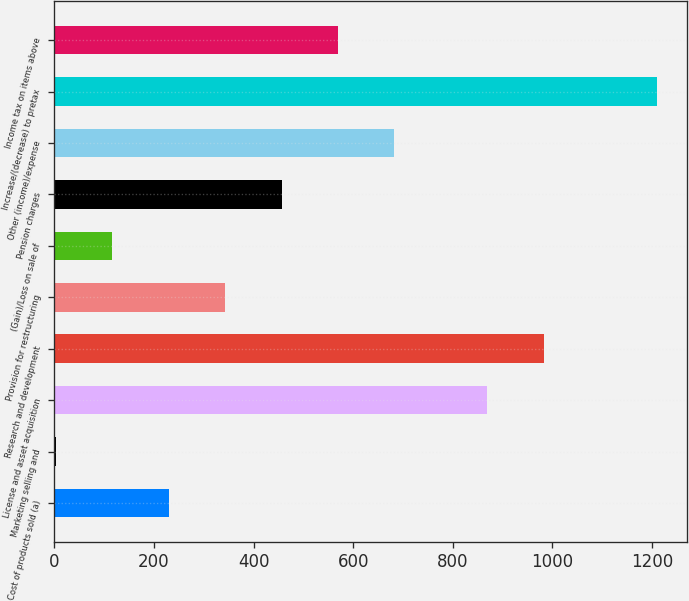Convert chart to OTSL. <chart><loc_0><loc_0><loc_500><loc_500><bar_chart><fcel>Cost of products sold (a)<fcel>Marketing selling and<fcel>License and asset acquisition<fcel>Research and development<fcel>Provision for restructuring<fcel>(Gain)/Loss on sale of<fcel>Pension charges<fcel>Other (income)/expense<fcel>Increase/(decrease) to pretax<fcel>Income tax on items above<nl><fcel>229.6<fcel>3<fcel>869<fcel>982.3<fcel>342.9<fcel>116.3<fcel>456.2<fcel>682.8<fcel>1208.9<fcel>569.5<nl></chart> 